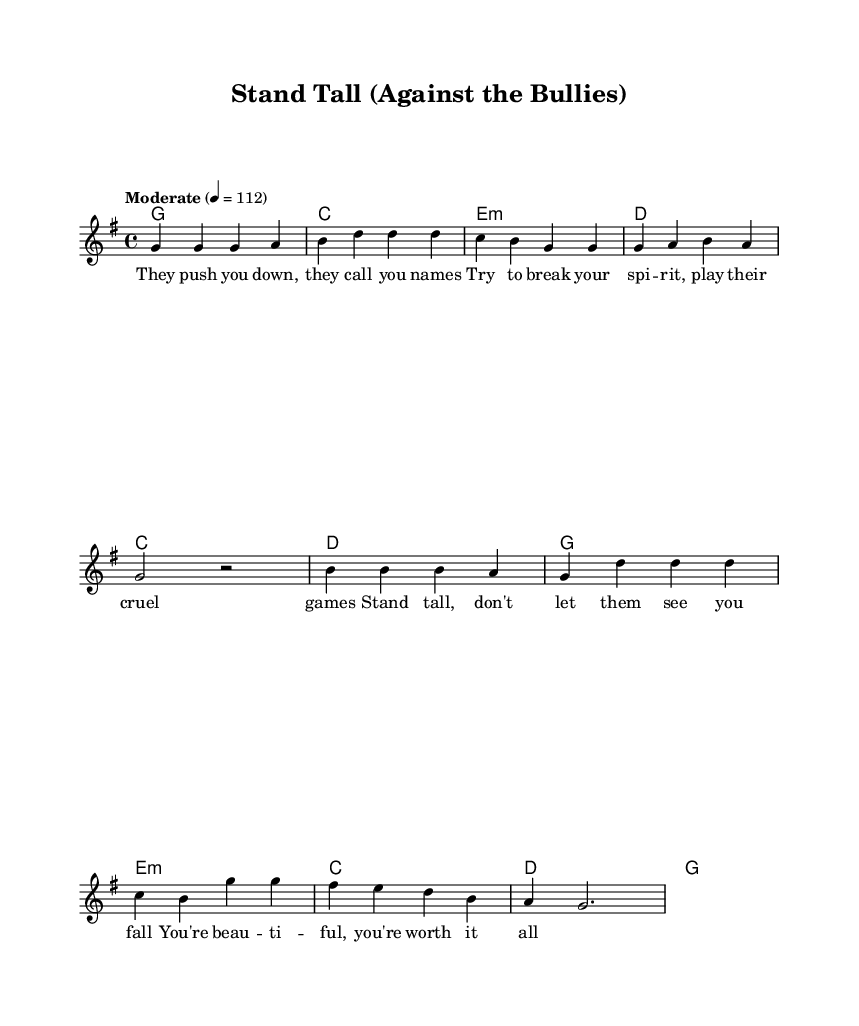What is the key signature of this music? The music is written in G major, which has one sharp (F#). The key signature can be identified at the beginning of the staff where it shows a single sharp marking.
Answer: G major What is the time signature of the piece? The time signature is located at the beginning of the score indicated by the '4/4' marking. This means there are four beats per measure and a quarter note gets one beat.
Answer: 4/4 What is the tempo marking for this song? The tempo is specified as "Moderate" and is indicated by the tempo marking at the beginning with a metronome indication of 112 beats per minute. This helps to establish the speed of the piece.
Answer: Moderate 4 = 112 How many measures are in the verse section? By counting the individual music phrases, the verse section consists of 4 measures represented by the note groupings before the chorus begins.
Answer: 4 What is the highest note in the melody? To find the highest note in the melody, we review the notes listed and identify that D is the highest pitch reached in the melody, which occurs in the chorus.
Answer: D What common theme do the lyrics address? The lyrics express a theme of resilience against bullying and highlight self-worth and confidence, emphasizing the importance of standing tall and recognizing one's value despite adversities.
Answer: Bullying and self-esteem What type of chord progression is used in the chorus? The chorus features a common progression in pop and country rock music which shifts through C, D, G, and E minor chords, indicating a typical major-minor tonality approach common in country rock.
Answer: C, D, G, E minor 